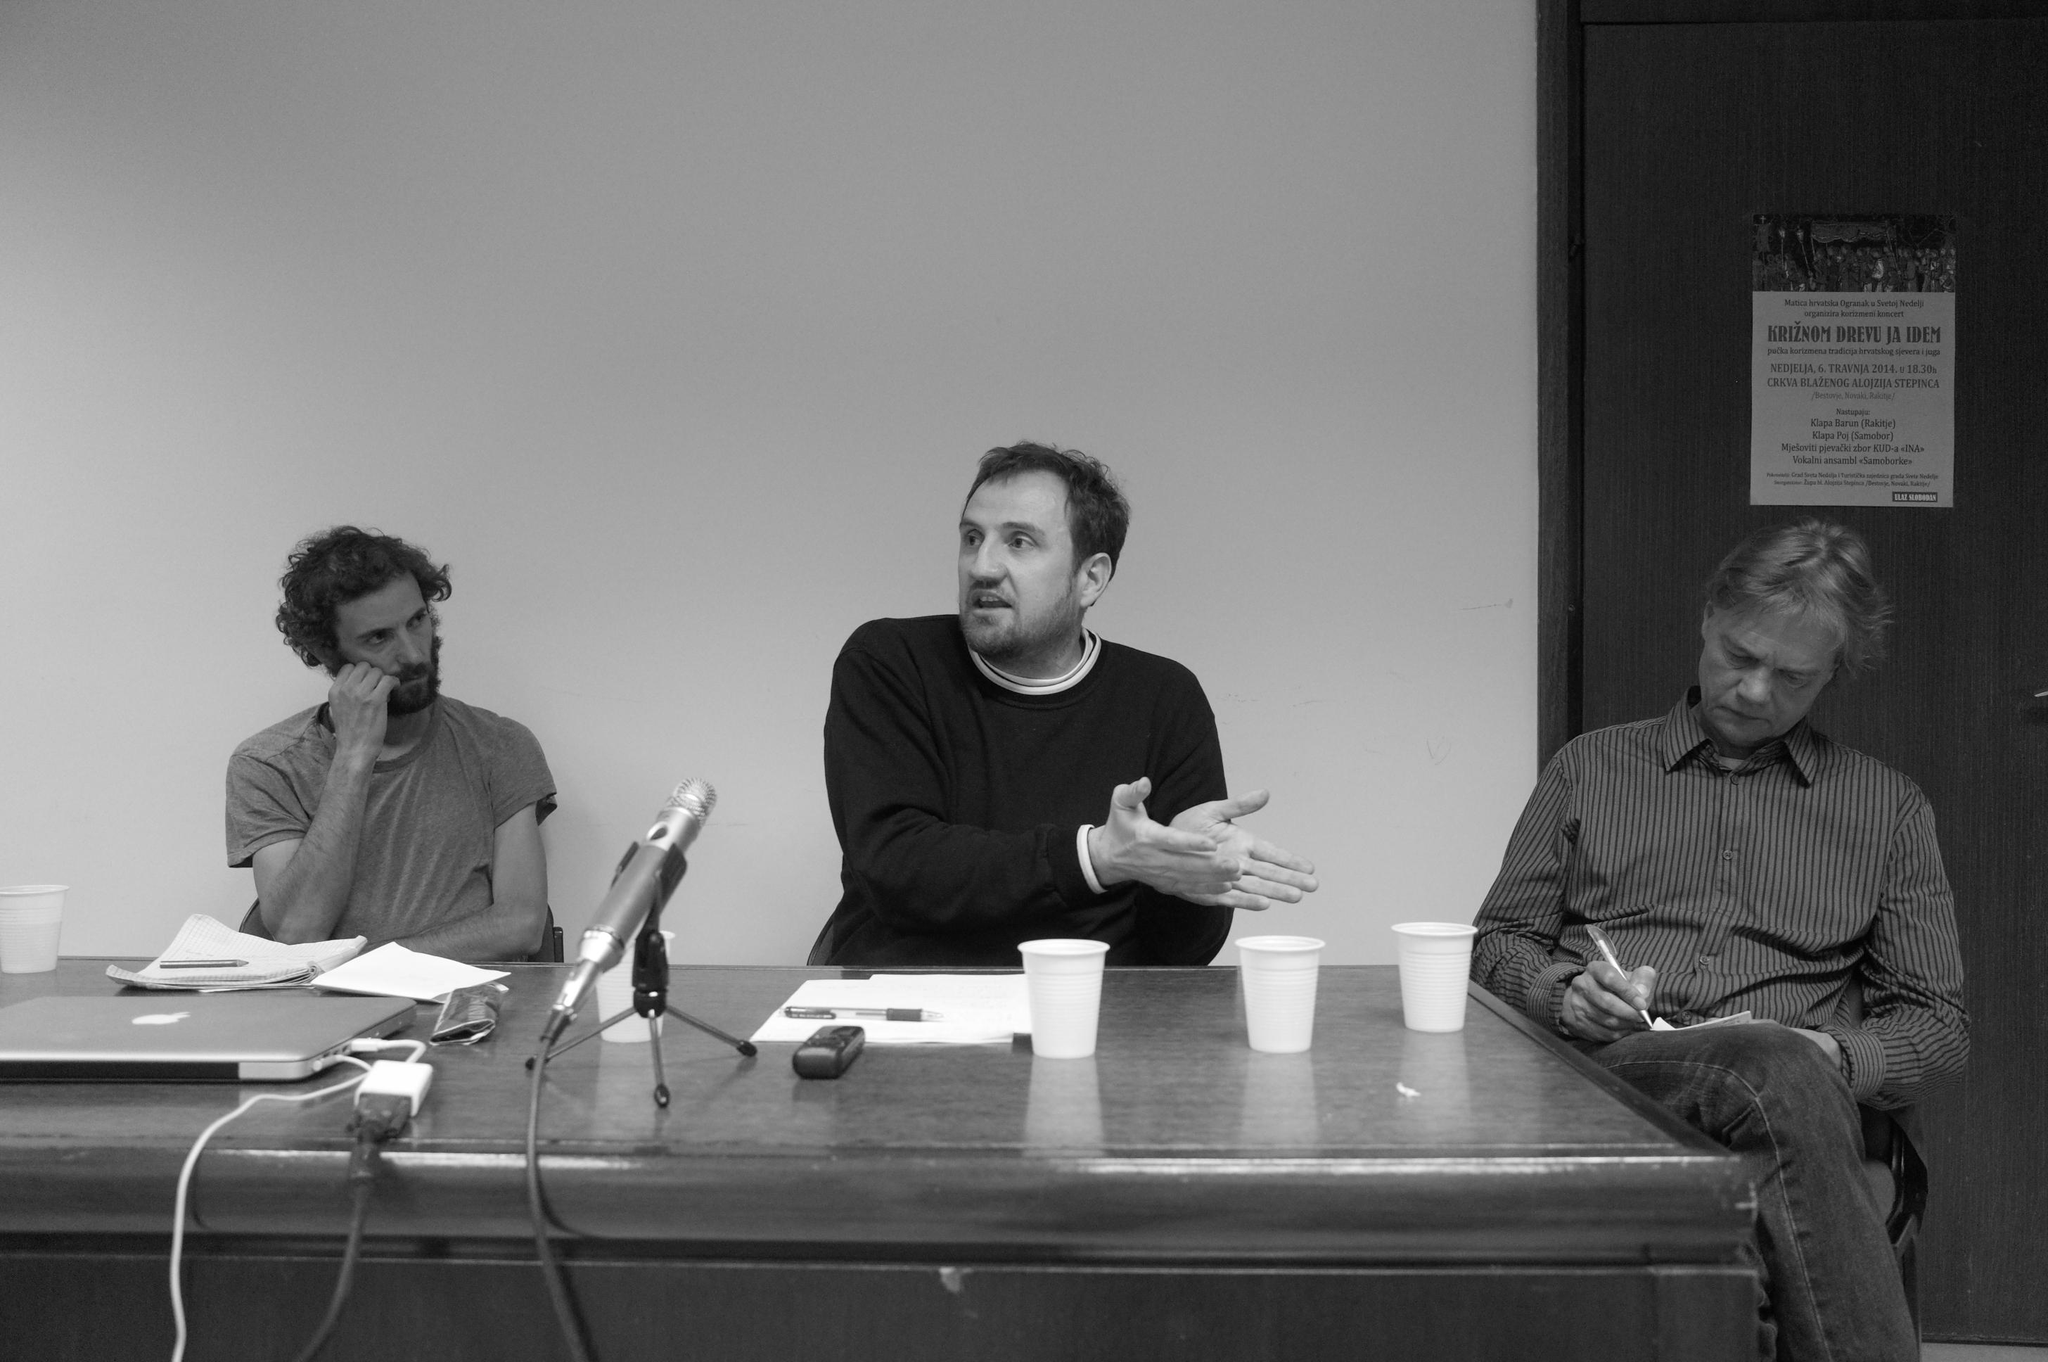What is the color scheme of the image? The image is black and white. How many persons are sitting on the chair in the image? There are three persons sitting on a chair in the image. What is in front of the persons? There is a table in front of the persons. What objects can be seen on the table? A mic, a mobile, a paper, a pen, a laptop, and cups are present on the table. What type of apple is being thought about by the persons in the image? There is no apple present in the image, nor is there any indication of thoughts or discussions about apples. Can you describe the clouds visible in the image? There are no clouds visible in the image, as it is a black and white image with no sky or outdoor setting. 